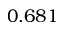Convert formula to latex. <formula><loc_0><loc_0><loc_500><loc_500>0 . 6 8 1</formula> 